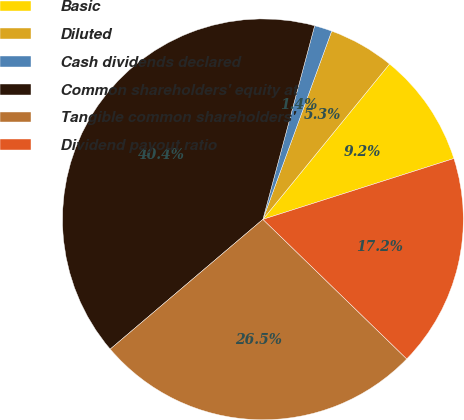<chart> <loc_0><loc_0><loc_500><loc_500><pie_chart><fcel>Basic<fcel>Diluted<fcel>Cash dividends declared<fcel>Common shareholders' equity at<fcel>Tangible common shareholders'<fcel>Dividend payout ratio<nl><fcel>9.21%<fcel>5.31%<fcel>1.42%<fcel>40.37%<fcel>26.53%<fcel>17.17%<nl></chart> 